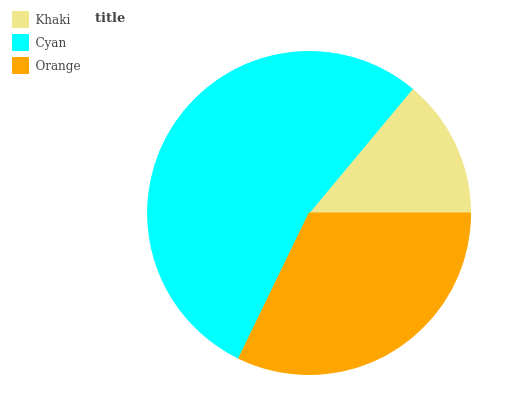Is Khaki the minimum?
Answer yes or no. Yes. Is Cyan the maximum?
Answer yes or no. Yes. Is Orange the minimum?
Answer yes or no. No. Is Orange the maximum?
Answer yes or no. No. Is Cyan greater than Orange?
Answer yes or no. Yes. Is Orange less than Cyan?
Answer yes or no. Yes. Is Orange greater than Cyan?
Answer yes or no. No. Is Cyan less than Orange?
Answer yes or no. No. Is Orange the high median?
Answer yes or no. Yes. Is Orange the low median?
Answer yes or no. Yes. Is Khaki the high median?
Answer yes or no. No. Is Cyan the low median?
Answer yes or no. No. 